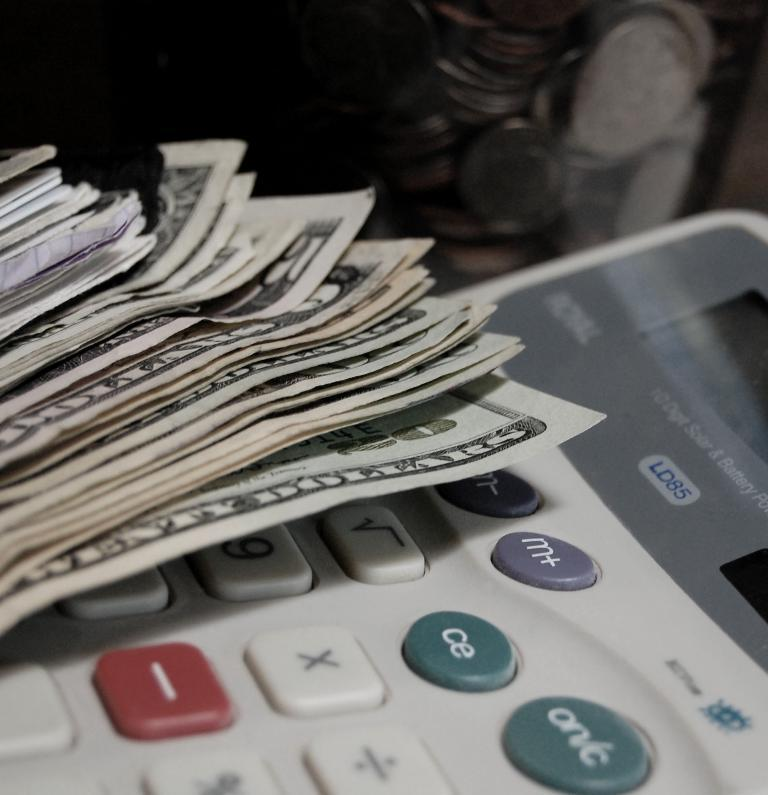<image>
Offer a succinct explanation of the picture presented. A stack of US currency laying on an LD85 10 digit solar and battery powered calculator. 